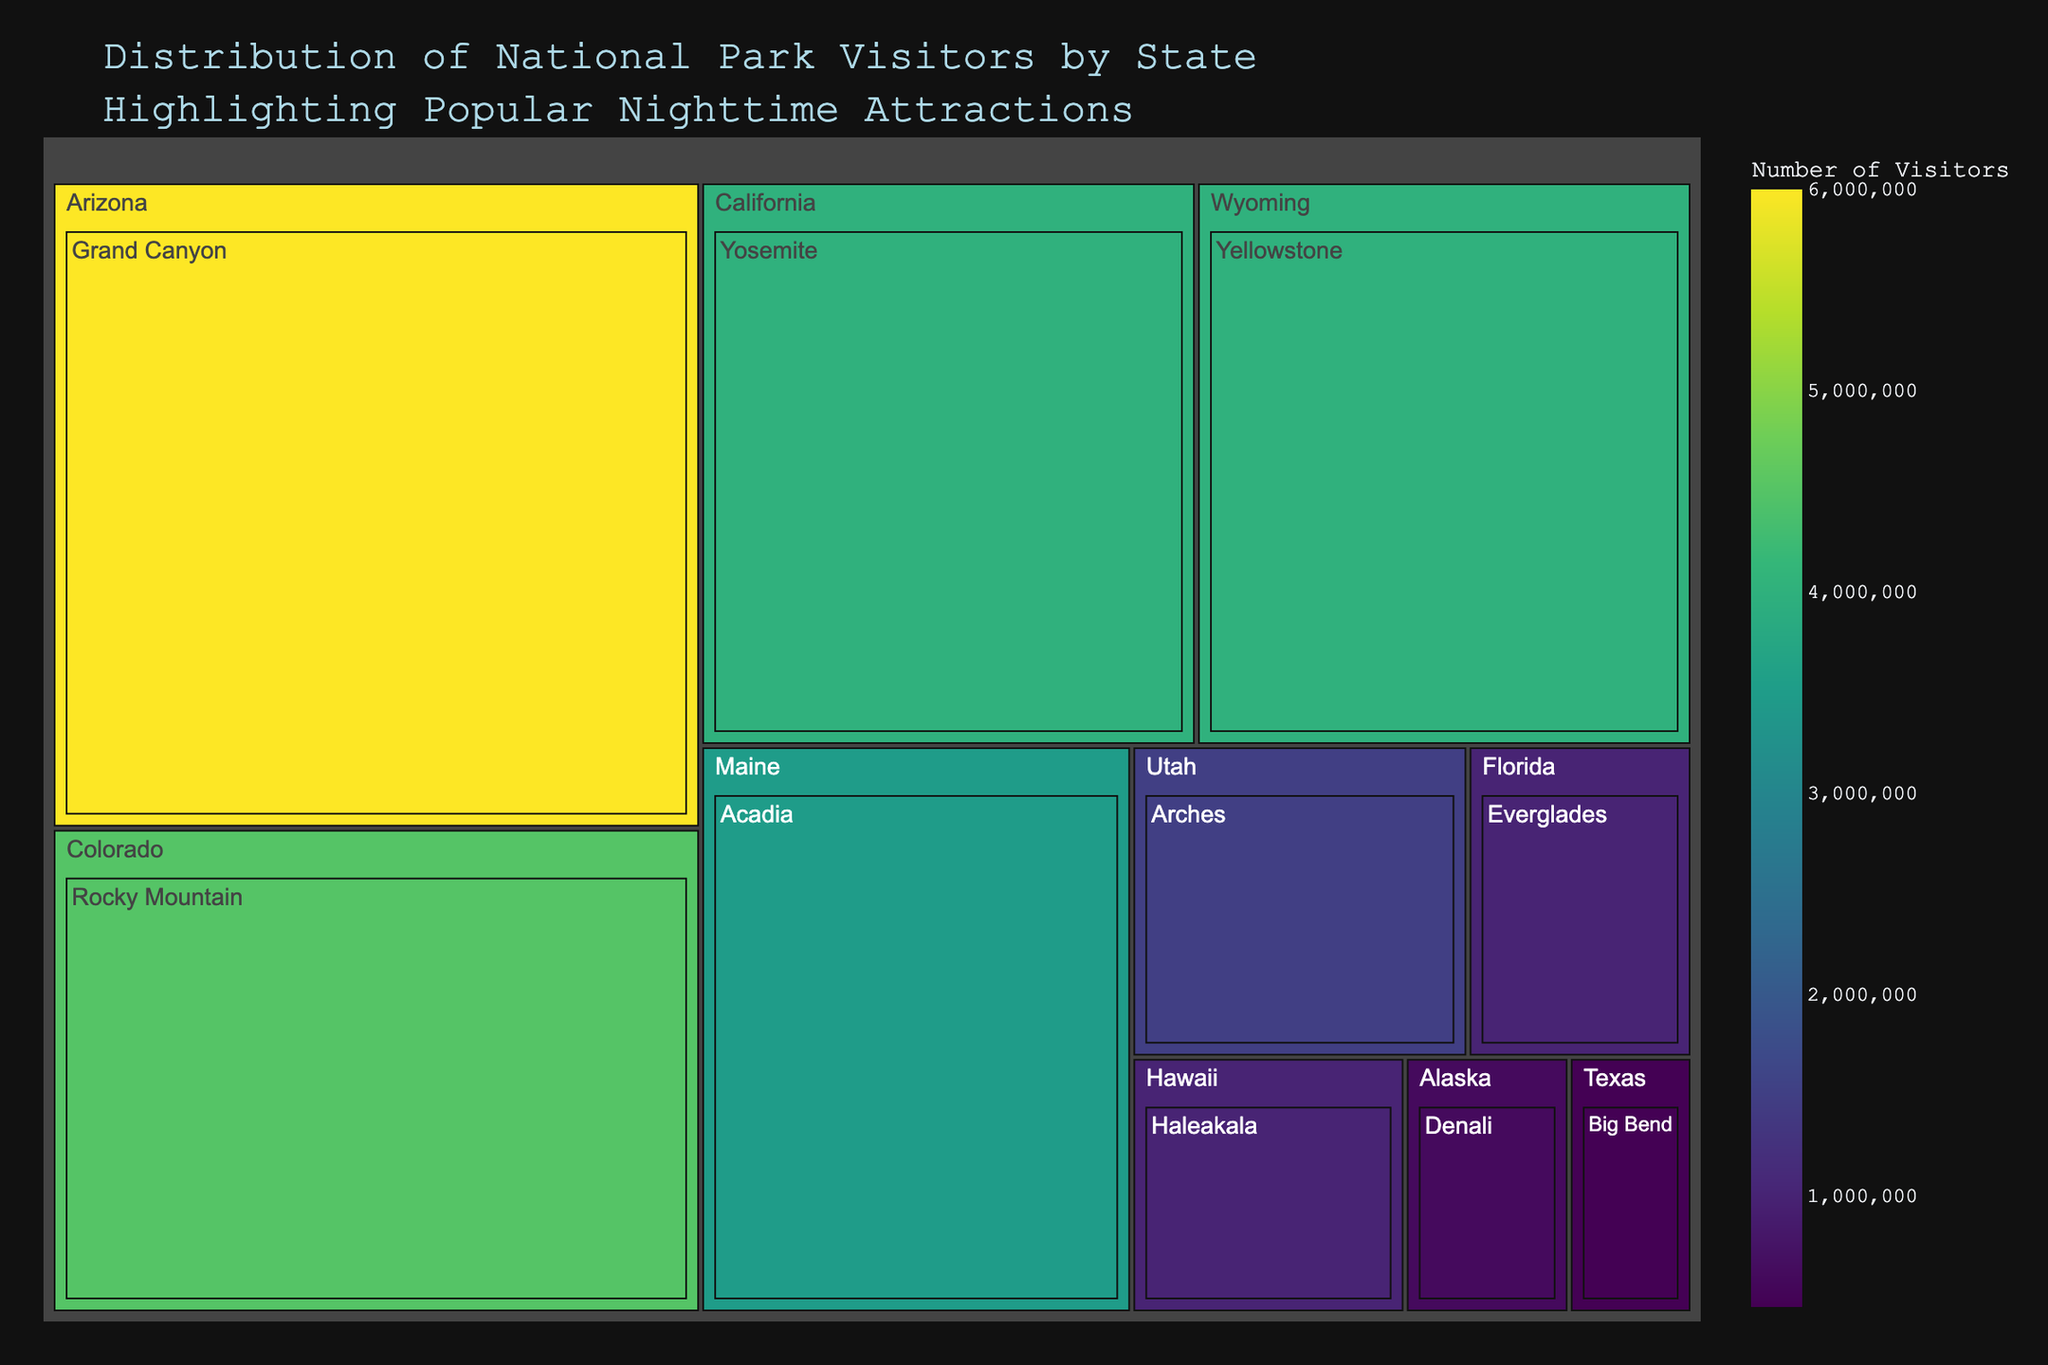Which state attracts the most visitors to its national parks? To find the state with the most visitors, look at the state with the largest area on the treemap. This state will have the highest cumulative number of visitors.
Answer: Arizona What is the title of the figure? The title is usually located at the top of the figure and provides an overview of what the treemap represents.
Answer: Distribution of National Park Visitors by State Highlighting Popular Nighttime Attractions Which national park in Colorado attracts visitors for its nighttime event? Hover over or look at the box representing Colorado, and find the park and its corresponding nighttime attraction.
Answer: Rocky Mountain, Night Sky Festival How many visitors does Yellowstone National Park in Wyoming receive? Locate the box for Wyoming, and then find Yellowstone National Park's specific area. The number of visitors will be displayed.
Answer: 4,000,000 Compare the number of visitors between Grand Canyon in Arizona and Denali in Alaska. Which park has more visitors? Look at the size of the boxes for Grand Canyon and Denali, or check the number of visitors indicated. Compare these values to determine which park has more visitors.
Answer: Grand Canyon What nighttime attraction is offered at Yosemite National Park in California? Identify the box for Yosemite National Park within California and check the hover data or description for its nighttime attraction.
Answer: Stargazing at Glacier Point Calculate the total number of visitors to the national parks in Utah and Texas combined. Locate Utah and Texas on the treemap, identify the visitor numbers for each park, and sum these values.
Answer: 1,950,000 Which state has the fewest visitors to its national parks? Find the smallest box on the treemap, as it represents the state with the lowest number of visitors.
Answer: Texas Do more people visit the parks in California or Hawaii? Compare the box sizes or aggregated visitor numbers for California and Hawaii visible on the treemap.
Answer: California Is the Northern Lights Viewing attraction associated with a park in the contiguous United States? Check the description or hover data for the Northern Lights Viewing event and identify its associated state.
Answer: No, it's in Alaska 